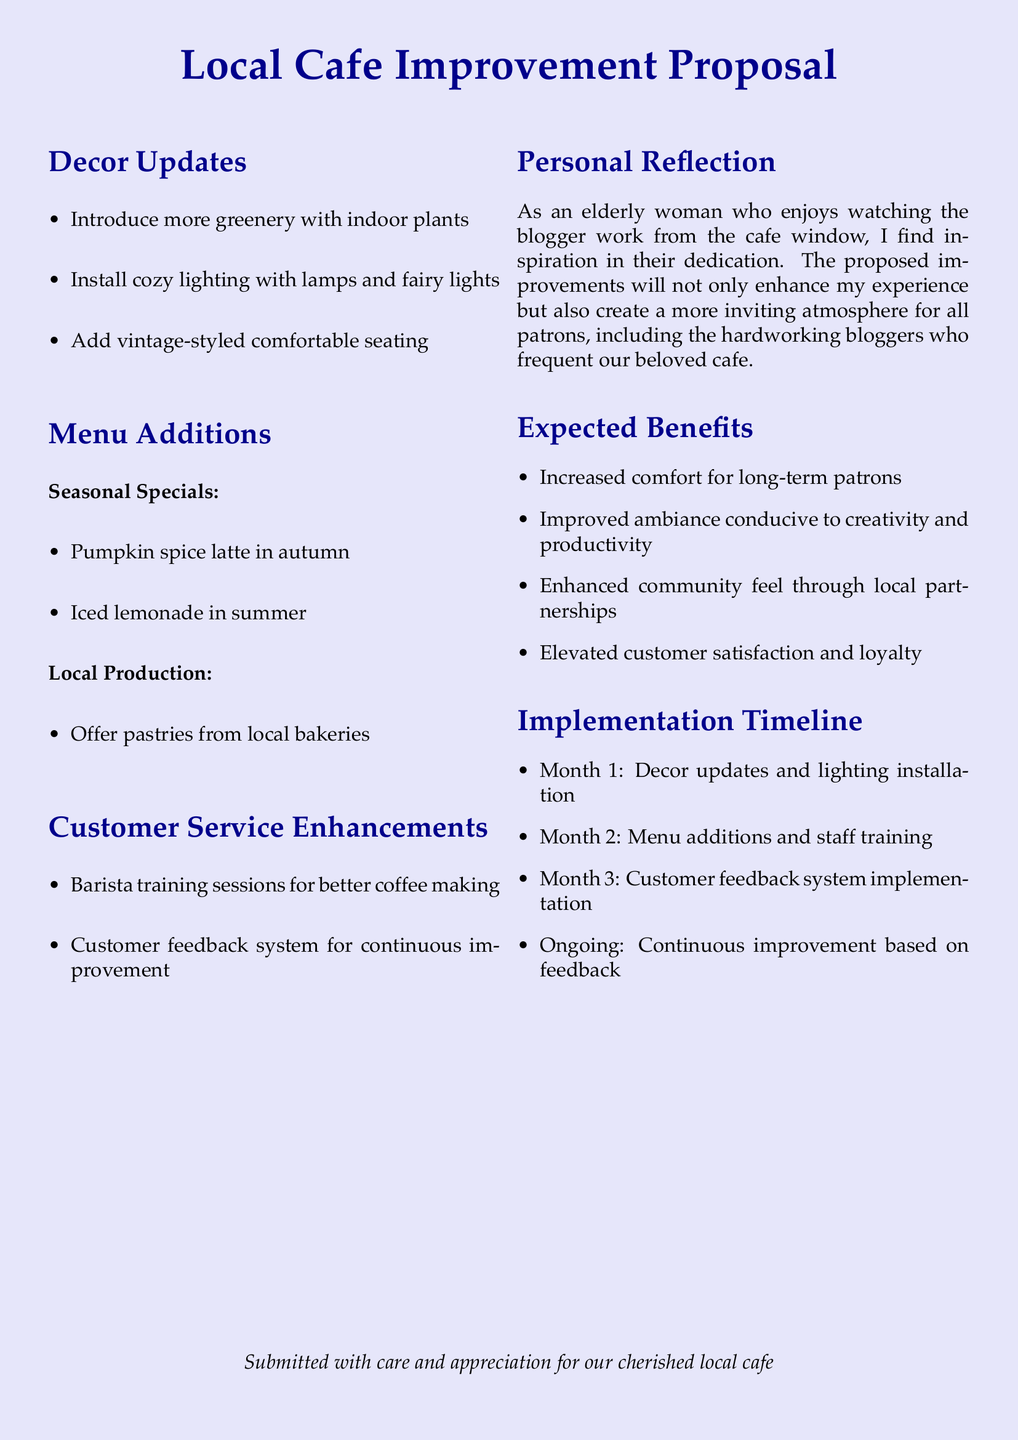What are the proposed decor updates? The decor updates include introducing greenery, installing cozy lighting, and adding vintage-styled seating.
Answer: Greenery, cozy lighting, vintage-styled seating What are the seasonal specials mentioned? The seasonal specials include specific drink offerings that change with the seasons. The document mentions pumpkin spice latte in autumn and iced lemonade in summer.
Answer: Pumpkin spice latte, iced lemonade What is the first month of the implementation timeline? The implementation timeline starts with decor updates and lighting installation during the first month.
Answer: Month 1 What type of training is proposed for baristas? The proposal includes training sessions aimed at improving barista skills in a specific area. It mentions barista training sessions for better coffee making.
Answer: Barista training What is an expected benefit of the cafe improvements? The document outlines several benefits related to customer experience and community feel. One expected benefit is increased comfort for long-term patrons.
Answer: Increased comfort What month is dedicated to menu additions? According to the implementation timeline, menu additions and staff training are scheduled for a specific month. That month is Month 2.
Answer: Month 2 What system is suggested for continuous improvement? A specific system for gathering feedback from customers is proposed to enhance service. It mentions a customer feedback system.
Answer: Customer feedback system What type of document is this? The content and structure of the document clearly indicate its purpose, which is to present a proposal for improvements.
Answer: Proposal 